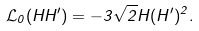Convert formula to latex. <formula><loc_0><loc_0><loc_500><loc_500>\mathcal { L } _ { 0 } ( H H ^ { \prime } ) = - 3 \sqrt { 2 } H ( H ^ { \prime } ) ^ { 2 } .</formula> 